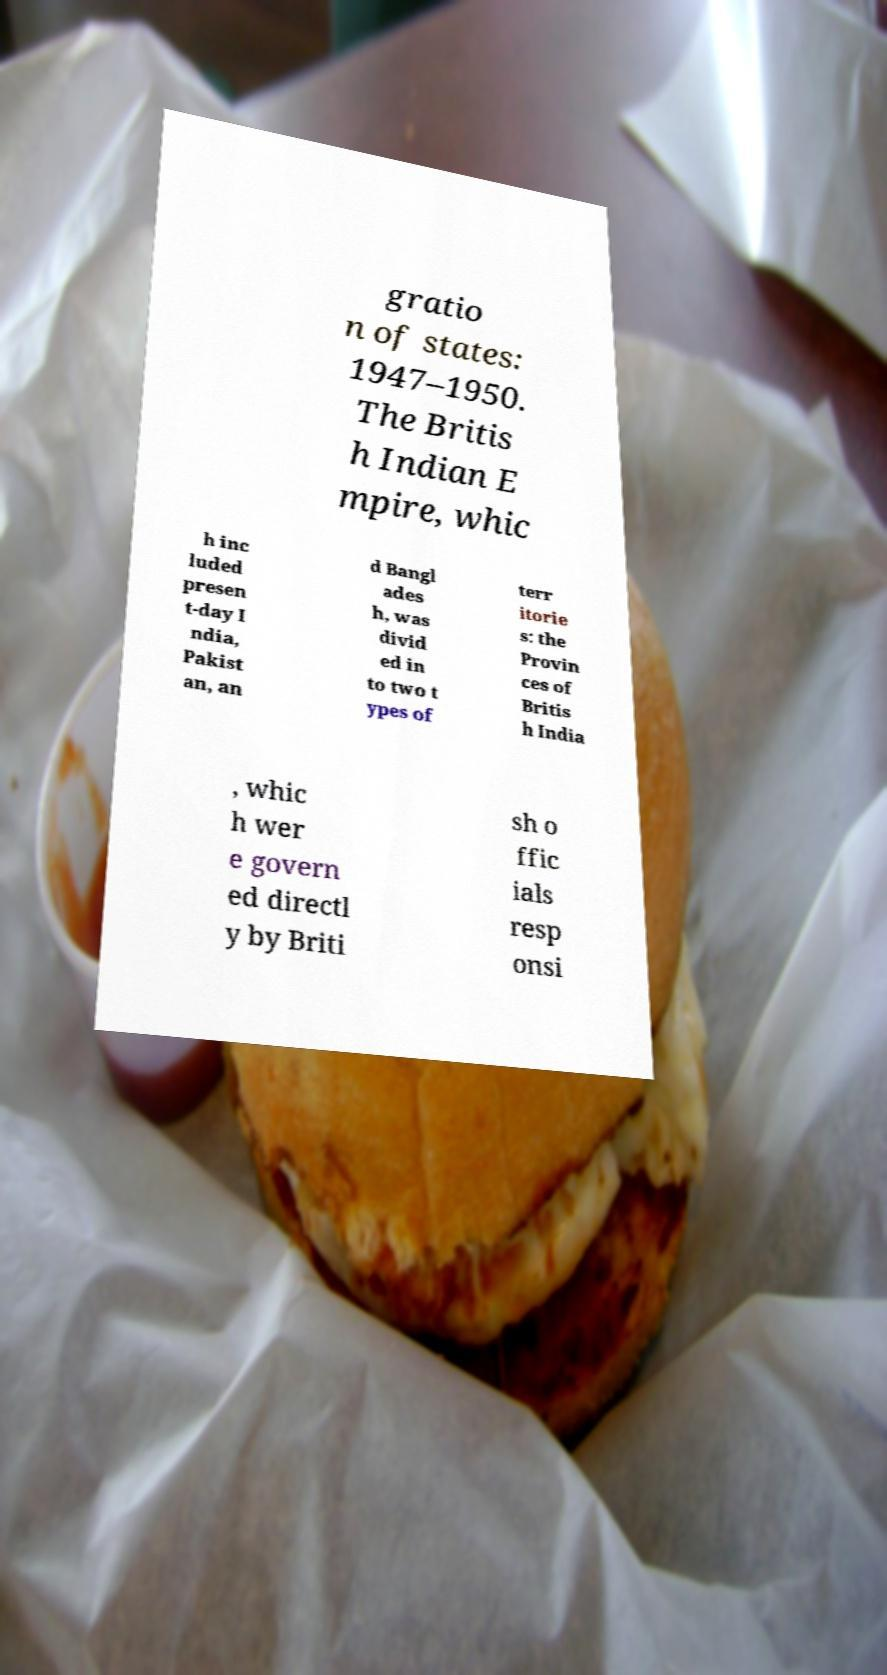Can you read and provide the text displayed in the image?This photo seems to have some interesting text. Can you extract and type it out for me? gratio n of states: 1947–1950. The Britis h Indian E mpire, whic h inc luded presen t-day I ndia, Pakist an, an d Bangl ades h, was divid ed in to two t ypes of terr itorie s: the Provin ces of Britis h India , whic h wer e govern ed directl y by Briti sh o ffic ials resp onsi 